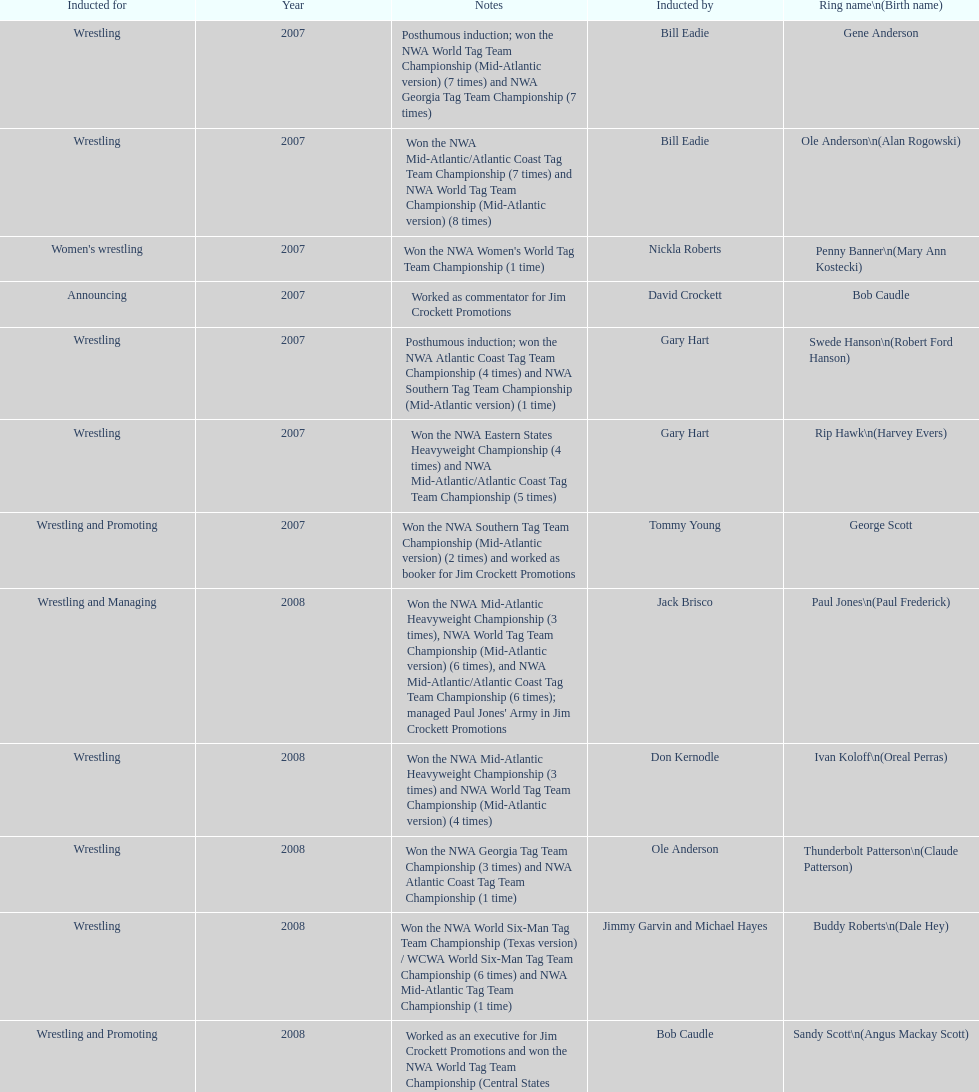Who won the most nwa southern tag team championships (mid-america version)? Jackie Fargo. 